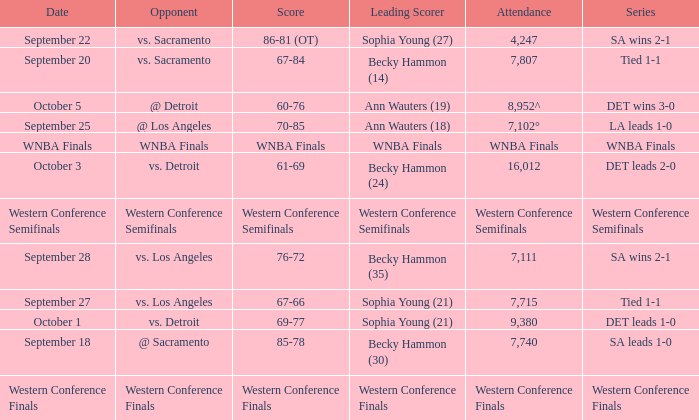Who is the opponent of the game with a tied 1-1 series and becky hammon (14) as the leading scorer? Vs. sacramento. 